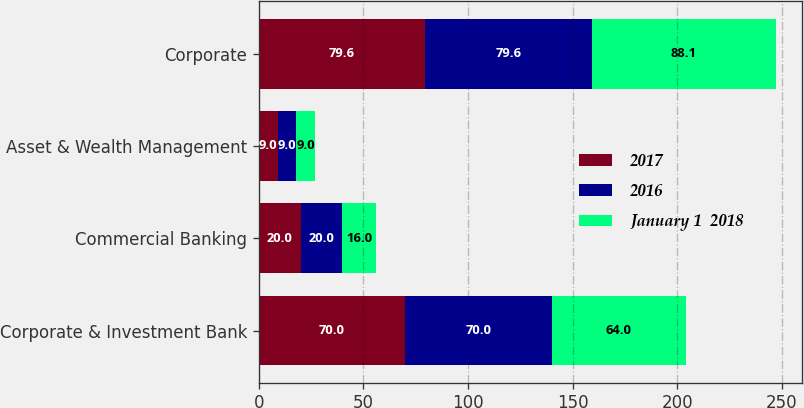Convert chart to OTSL. <chart><loc_0><loc_0><loc_500><loc_500><stacked_bar_chart><ecel><fcel>Corporate & Investment Bank<fcel>Commercial Banking<fcel>Asset & Wealth Management<fcel>Corporate<nl><fcel>2017<fcel>70<fcel>20<fcel>9<fcel>79.6<nl><fcel>2016<fcel>70<fcel>20<fcel>9<fcel>79.6<nl><fcel>January 1  2018<fcel>64<fcel>16<fcel>9<fcel>88.1<nl></chart> 